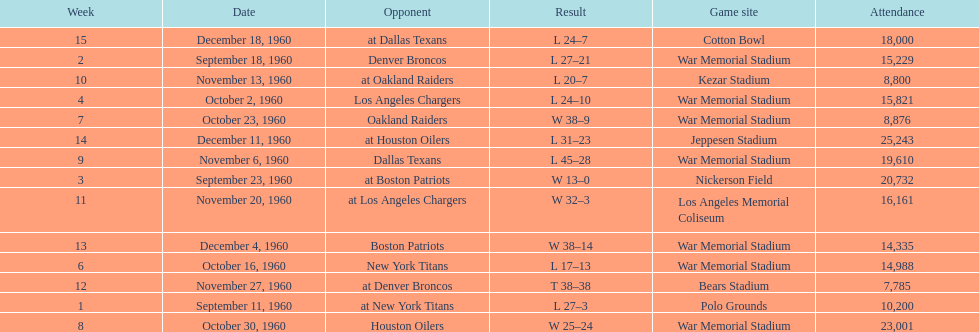What date was the first game at war memorial stadium? September 18, 1960. 